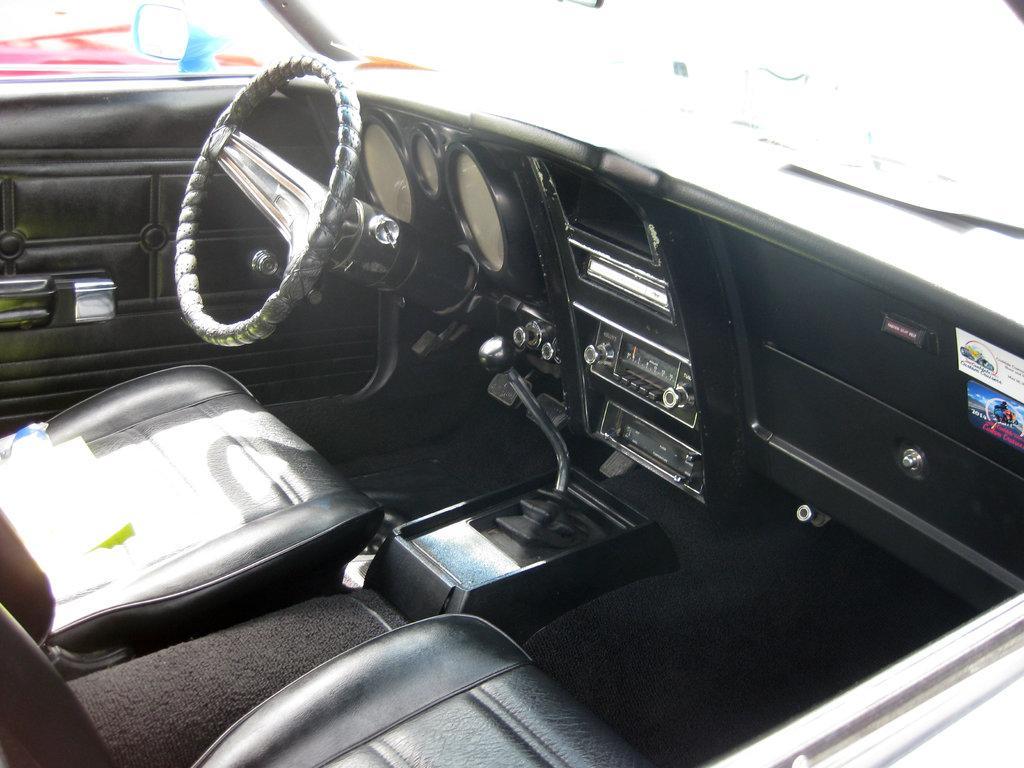Can you describe this image briefly? In this picture, it seems to be the view of a car from inside, it includes steering, speedometer, seats and other parts. 